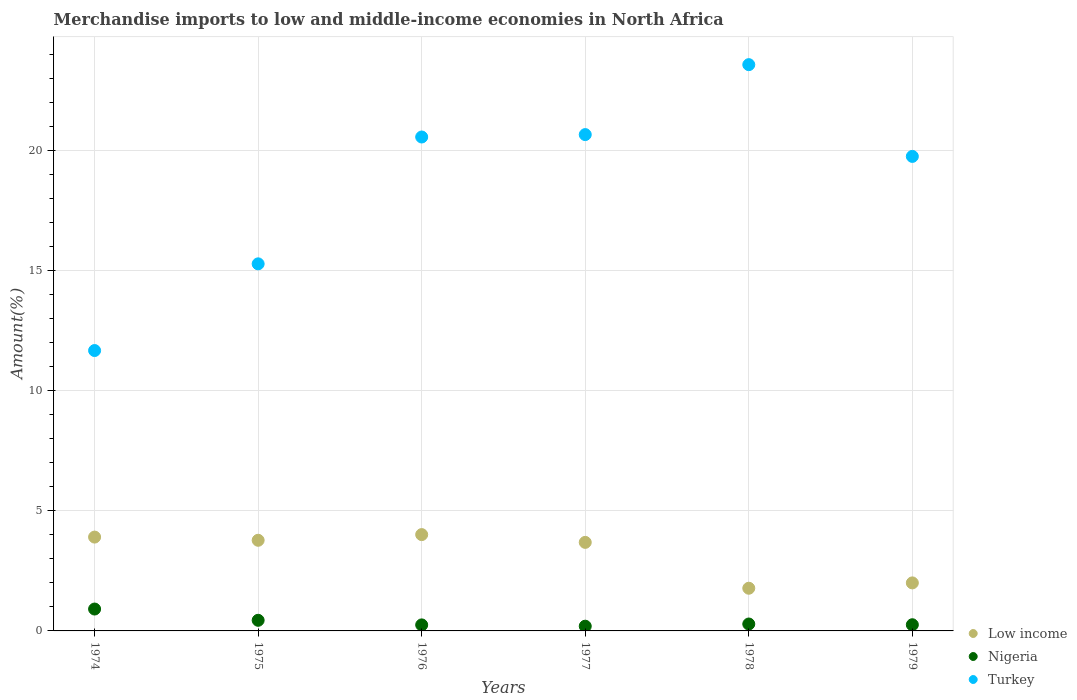How many different coloured dotlines are there?
Give a very brief answer. 3. Is the number of dotlines equal to the number of legend labels?
Make the answer very short. Yes. What is the percentage of amount earned from merchandise imports in Turkey in 1974?
Give a very brief answer. 11.68. Across all years, what is the maximum percentage of amount earned from merchandise imports in Turkey?
Keep it short and to the point. 23.6. Across all years, what is the minimum percentage of amount earned from merchandise imports in Turkey?
Offer a very short reply. 11.68. In which year was the percentage of amount earned from merchandise imports in Low income maximum?
Give a very brief answer. 1976. In which year was the percentage of amount earned from merchandise imports in Turkey minimum?
Provide a short and direct response. 1974. What is the total percentage of amount earned from merchandise imports in Low income in the graph?
Make the answer very short. 19.17. What is the difference between the percentage of amount earned from merchandise imports in Turkey in 1974 and that in 1976?
Keep it short and to the point. -8.9. What is the difference between the percentage of amount earned from merchandise imports in Low income in 1975 and the percentage of amount earned from merchandise imports in Turkey in 1978?
Offer a very short reply. -19.82. What is the average percentage of amount earned from merchandise imports in Turkey per year?
Offer a terse response. 18.6. In the year 1977, what is the difference between the percentage of amount earned from merchandise imports in Low income and percentage of amount earned from merchandise imports in Nigeria?
Your answer should be compact. 3.49. In how many years, is the percentage of amount earned from merchandise imports in Low income greater than 6 %?
Keep it short and to the point. 0. What is the ratio of the percentage of amount earned from merchandise imports in Low income in 1974 to that in 1978?
Ensure brevity in your answer.  2.2. Is the percentage of amount earned from merchandise imports in Nigeria in 1974 less than that in 1976?
Your response must be concise. No. What is the difference between the highest and the second highest percentage of amount earned from merchandise imports in Turkey?
Make the answer very short. 2.91. What is the difference between the highest and the lowest percentage of amount earned from merchandise imports in Low income?
Your answer should be very brief. 2.24. In how many years, is the percentage of amount earned from merchandise imports in Turkey greater than the average percentage of amount earned from merchandise imports in Turkey taken over all years?
Provide a short and direct response. 4. Is the percentage of amount earned from merchandise imports in Turkey strictly greater than the percentage of amount earned from merchandise imports in Low income over the years?
Provide a short and direct response. Yes. What is the difference between two consecutive major ticks on the Y-axis?
Your answer should be very brief. 5. Does the graph contain any zero values?
Provide a succinct answer. No. Does the graph contain grids?
Your answer should be compact. Yes. Where does the legend appear in the graph?
Your response must be concise. Bottom right. How are the legend labels stacked?
Your response must be concise. Vertical. What is the title of the graph?
Keep it short and to the point. Merchandise imports to low and middle-income economies in North Africa. What is the label or title of the Y-axis?
Your answer should be compact. Amount(%). What is the Amount(%) of Low income in 1974?
Your answer should be compact. 3.91. What is the Amount(%) of Nigeria in 1974?
Your response must be concise. 0.91. What is the Amount(%) of Turkey in 1974?
Your answer should be very brief. 11.68. What is the Amount(%) of Low income in 1975?
Your response must be concise. 3.78. What is the Amount(%) in Nigeria in 1975?
Your response must be concise. 0.44. What is the Amount(%) in Turkey in 1975?
Keep it short and to the point. 15.3. What is the Amount(%) of Low income in 1976?
Your response must be concise. 4.01. What is the Amount(%) of Nigeria in 1976?
Ensure brevity in your answer.  0.25. What is the Amount(%) in Turkey in 1976?
Provide a succinct answer. 20.58. What is the Amount(%) in Low income in 1977?
Provide a succinct answer. 3.69. What is the Amount(%) in Nigeria in 1977?
Your response must be concise. 0.2. What is the Amount(%) in Turkey in 1977?
Provide a short and direct response. 20.68. What is the Amount(%) in Low income in 1978?
Your response must be concise. 1.78. What is the Amount(%) of Nigeria in 1978?
Provide a short and direct response. 0.29. What is the Amount(%) of Turkey in 1978?
Give a very brief answer. 23.6. What is the Amount(%) of Low income in 1979?
Provide a succinct answer. 2. What is the Amount(%) of Nigeria in 1979?
Your answer should be compact. 0.26. What is the Amount(%) in Turkey in 1979?
Your answer should be compact. 19.77. Across all years, what is the maximum Amount(%) of Low income?
Give a very brief answer. 4.01. Across all years, what is the maximum Amount(%) in Nigeria?
Give a very brief answer. 0.91. Across all years, what is the maximum Amount(%) in Turkey?
Make the answer very short. 23.6. Across all years, what is the minimum Amount(%) in Low income?
Your answer should be very brief. 1.78. Across all years, what is the minimum Amount(%) in Nigeria?
Your answer should be very brief. 0.2. Across all years, what is the minimum Amount(%) of Turkey?
Make the answer very short. 11.68. What is the total Amount(%) in Low income in the graph?
Offer a very short reply. 19.17. What is the total Amount(%) in Nigeria in the graph?
Your response must be concise. 2.35. What is the total Amount(%) in Turkey in the graph?
Your answer should be compact. 111.62. What is the difference between the Amount(%) in Low income in 1974 and that in 1975?
Make the answer very short. 0.13. What is the difference between the Amount(%) of Nigeria in 1974 and that in 1975?
Your answer should be very brief. 0.47. What is the difference between the Amount(%) in Turkey in 1974 and that in 1975?
Your answer should be compact. -3.61. What is the difference between the Amount(%) of Low income in 1974 and that in 1976?
Keep it short and to the point. -0.1. What is the difference between the Amount(%) in Nigeria in 1974 and that in 1976?
Offer a very short reply. 0.66. What is the difference between the Amount(%) of Turkey in 1974 and that in 1976?
Offer a terse response. -8.9. What is the difference between the Amount(%) of Low income in 1974 and that in 1977?
Provide a short and direct response. 0.22. What is the difference between the Amount(%) of Nigeria in 1974 and that in 1977?
Provide a succinct answer. 0.72. What is the difference between the Amount(%) in Turkey in 1974 and that in 1977?
Provide a succinct answer. -9. What is the difference between the Amount(%) in Low income in 1974 and that in 1978?
Your response must be concise. 2.13. What is the difference between the Amount(%) in Nigeria in 1974 and that in 1978?
Provide a succinct answer. 0.62. What is the difference between the Amount(%) in Turkey in 1974 and that in 1978?
Offer a very short reply. -11.91. What is the difference between the Amount(%) of Low income in 1974 and that in 1979?
Keep it short and to the point. 1.91. What is the difference between the Amount(%) of Nigeria in 1974 and that in 1979?
Give a very brief answer. 0.65. What is the difference between the Amount(%) in Turkey in 1974 and that in 1979?
Your response must be concise. -8.09. What is the difference between the Amount(%) of Low income in 1975 and that in 1976?
Give a very brief answer. -0.24. What is the difference between the Amount(%) of Nigeria in 1975 and that in 1976?
Give a very brief answer. 0.19. What is the difference between the Amount(%) of Turkey in 1975 and that in 1976?
Ensure brevity in your answer.  -5.29. What is the difference between the Amount(%) of Low income in 1975 and that in 1977?
Give a very brief answer. 0.09. What is the difference between the Amount(%) in Nigeria in 1975 and that in 1977?
Keep it short and to the point. 0.25. What is the difference between the Amount(%) in Turkey in 1975 and that in 1977?
Make the answer very short. -5.39. What is the difference between the Amount(%) of Low income in 1975 and that in 1978?
Your response must be concise. 2. What is the difference between the Amount(%) in Nigeria in 1975 and that in 1978?
Your answer should be very brief. 0.15. What is the difference between the Amount(%) of Turkey in 1975 and that in 1978?
Your answer should be very brief. -8.3. What is the difference between the Amount(%) in Low income in 1975 and that in 1979?
Offer a terse response. 1.78. What is the difference between the Amount(%) of Nigeria in 1975 and that in 1979?
Provide a succinct answer. 0.19. What is the difference between the Amount(%) of Turkey in 1975 and that in 1979?
Your answer should be compact. -4.48. What is the difference between the Amount(%) of Low income in 1976 and that in 1977?
Your response must be concise. 0.32. What is the difference between the Amount(%) in Nigeria in 1976 and that in 1977?
Offer a very short reply. 0.05. What is the difference between the Amount(%) in Turkey in 1976 and that in 1977?
Give a very brief answer. -0.1. What is the difference between the Amount(%) of Low income in 1976 and that in 1978?
Provide a short and direct response. 2.24. What is the difference between the Amount(%) in Nigeria in 1976 and that in 1978?
Ensure brevity in your answer.  -0.04. What is the difference between the Amount(%) of Turkey in 1976 and that in 1978?
Your answer should be compact. -3.01. What is the difference between the Amount(%) in Low income in 1976 and that in 1979?
Your answer should be very brief. 2.01. What is the difference between the Amount(%) of Nigeria in 1976 and that in 1979?
Keep it short and to the point. -0.01. What is the difference between the Amount(%) of Turkey in 1976 and that in 1979?
Provide a succinct answer. 0.81. What is the difference between the Amount(%) of Low income in 1977 and that in 1978?
Keep it short and to the point. 1.91. What is the difference between the Amount(%) of Nigeria in 1977 and that in 1978?
Your response must be concise. -0.09. What is the difference between the Amount(%) of Turkey in 1977 and that in 1978?
Offer a terse response. -2.91. What is the difference between the Amount(%) of Low income in 1977 and that in 1979?
Give a very brief answer. 1.69. What is the difference between the Amount(%) of Nigeria in 1977 and that in 1979?
Offer a terse response. -0.06. What is the difference between the Amount(%) in Turkey in 1977 and that in 1979?
Provide a succinct answer. 0.91. What is the difference between the Amount(%) in Low income in 1978 and that in 1979?
Your answer should be compact. -0.22. What is the difference between the Amount(%) in Nigeria in 1978 and that in 1979?
Provide a succinct answer. 0.03. What is the difference between the Amount(%) of Turkey in 1978 and that in 1979?
Your answer should be compact. 3.82. What is the difference between the Amount(%) of Low income in 1974 and the Amount(%) of Nigeria in 1975?
Offer a very short reply. 3.47. What is the difference between the Amount(%) in Low income in 1974 and the Amount(%) in Turkey in 1975?
Ensure brevity in your answer.  -11.39. What is the difference between the Amount(%) in Nigeria in 1974 and the Amount(%) in Turkey in 1975?
Provide a succinct answer. -14.38. What is the difference between the Amount(%) of Low income in 1974 and the Amount(%) of Nigeria in 1976?
Make the answer very short. 3.66. What is the difference between the Amount(%) of Low income in 1974 and the Amount(%) of Turkey in 1976?
Your response must be concise. -16.67. What is the difference between the Amount(%) in Nigeria in 1974 and the Amount(%) in Turkey in 1976?
Offer a terse response. -19.67. What is the difference between the Amount(%) of Low income in 1974 and the Amount(%) of Nigeria in 1977?
Your response must be concise. 3.71. What is the difference between the Amount(%) in Low income in 1974 and the Amount(%) in Turkey in 1977?
Offer a terse response. -16.77. What is the difference between the Amount(%) in Nigeria in 1974 and the Amount(%) in Turkey in 1977?
Make the answer very short. -19.77. What is the difference between the Amount(%) of Low income in 1974 and the Amount(%) of Nigeria in 1978?
Give a very brief answer. 3.62. What is the difference between the Amount(%) in Low income in 1974 and the Amount(%) in Turkey in 1978?
Offer a terse response. -19.69. What is the difference between the Amount(%) of Nigeria in 1974 and the Amount(%) of Turkey in 1978?
Your answer should be very brief. -22.68. What is the difference between the Amount(%) in Low income in 1974 and the Amount(%) in Nigeria in 1979?
Keep it short and to the point. 3.65. What is the difference between the Amount(%) of Low income in 1974 and the Amount(%) of Turkey in 1979?
Provide a succinct answer. -15.86. What is the difference between the Amount(%) in Nigeria in 1974 and the Amount(%) in Turkey in 1979?
Keep it short and to the point. -18.86. What is the difference between the Amount(%) in Low income in 1975 and the Amount(%) in Nigeria in 1976?
Offer a terse response. 3.53. What is the difference between the Amount(%) in Low income in 1975 and the Amount(%) in Turkey in 1976?
Keep it short and to the point. -16.81. What is the difference between the Amount(%) in Nigeria in 1975 and the Amount(%) in Turkey in 1976?
Offer a very short reply. -20.14. What is the difference between the Amount(%) of Low income in 1975 and the Amount(%) of Nigeria in 1977?
Offer a terse response. 3.58. What is the difference between the Amount(%) of Low income in 1975 and the Amount(%) of Turkey in 1977?
Make the answer very short. -16.91. What is the difference between the Amount(%) in Nigeria in 1975 and the Amount(%) in Turkey in 1977?
Offer a very short reply. -20.24. What is the difference between the Amount(%) of Low income in 1975 and the Amount(%) of Nigeria in 1978?
Offer a terse response. 3.49. What is the difference between the Amount(%) in Low income in 1975 and the Amount(%) in Turkey in 1978?
Offer a very short reply. -19.82. What is the difference between the Amount(%) of Nigeria in 1975 and the Amount(%) of Turkey in 1978?
Your answer should be very brief. -23.15. What is the difference between the Amount(%) of Low income in 1975 and the Amount(%) of Nigeria in 1979?
Your response must be concise. 3.52. What is the difference between the Amount(%) of Low income in 1975 and the Amount(%) of Turkey in 1979?
Provide a succinct answer. -16. What is the difference between the Amount(%) of Nigeria in 1975 and the Amount(%) of Turkey in 1979?
Give a very brief answer. -19.33. What is the difference between the Amount(%) in Low income in 1976 and the Amount(%) in Nigeria in 1977?
Keep it short and to the point. 3.82. What is the difference between the Amount(%) of Low income in 1976 and the Amount(%) of Turkey in 1977?
Offer a very short reply. -16.67. What is the difference between the Amount(%) in Nigeria in 1976 and the Amount(%) in Turkey in 1977?
Keep it short and to the point. -20.43. What is the difference between the Amount(%) of Low income in 1976 and the Amount(%) of Nigeria in 1978?
Provide a short and direct response. 3.73. What is the difference between the Amount(%) in Low income in 1976 and the Amount(%) in Turkey in 1978?
Ensure brevity in your answer.  -19.58. What is the difference between the Amount(%) of Nigeria in 1976 and the Amount(%) of Turkey in 1978?
Ensure brevity in your answer.  -23.35. What is the difference between the Amount(%) of Low income in 1976 and the Amount(%) of Nigeria in 1979?
Ensure brevity in your answer.  3.76. What is the difference between the Amount(%) of Low income in 1976 and the Amount(%) of Turkey in 1979?
Your answer should be very brief. -15.76. What is the difference between the Amount(%) of Nigeria in 1976 and the Amount(%) of Turkey in 1979?
Provide a succinct answer. -19.52. What is the difference between the Amount(%) in Low income in 1977 and the Amount(%) in Nigeria in 1978?
Give a very brief answer. 3.4. What is the difference between the Amount(%) of Low income in 1977 and the Amount(%) of Turkey in 1978?
Make the answer very short. -19.91. What is the difference between the Amount(%) of Nigeria in 1977 and the Amount(%) of Turkey in 1978?
Your answer should be compact. -23.4. What is the difference between the Amount(%) in Low income in 1977 and the Amount(%) in Nigeria in 1979?
Ensure brevity in your answer.  3.43. What is the difference between the Amount(%) of Low income in 1977 and the Amount(%) of Turkey in 1979?
Provide a succinct answer. -16.08. What is the difference between the Amount(%) of Nigeria in 1977 and the Amount(%) of Turkey in 1979?
Provide a succinct answer. -19.58. What is the difference between the Amount(%) in Low income in 1978 and the Amount(%) in Nigeria in 1979?
Your answer should be very brief. 1.52. What is the difference between the Amount(%) in Low income in 1978 and the Amount(%) in Turkey in 1979?
Your response must be concise. -18. What is the difference between the Amount(%) of Nigeria in 1978 and the Amount(%) of Turkey in 1979?
Ensure brevity in your answer.  -19.49. What is the average Amount(%) of Low income per year?
Provide a succinct answer. 3.2. What is the average Amount(%) in Nigeria per year?
Your answer should be compact. 0.39. What is the average Amount(%) in Turkey per year?
Keep it short and to the point. 18.6. In the year 1974, what is the difference between the Amount(%) in Low income and Amount(%) in Nigeria?
Ensure brevity in your answer.  3. In the year 1974, what is the difference between the Amount(%) of Low income and Amount(%) of Turkey?
Provide a succinct answer. -7.77. In the year 1974, what is the difference between the Amount(%) in Nigeria and Amount(%) in Turkey?
Offer a terse response. -10.77. In the year 1975, what is the difference between the Amount(%) of Low income and Amount(%) of Nigeria?
Ensure brevity in your answer.  3.33. In the year 1975, what is the difference between the Amount(%) in Low income and Amount(%) in Turkey?
Ensure brevity in your answer.  -11.52. In the year 1975, what is the difference between the Amount(%) of Nigeria and Amount(%) of Turkey?
Your response must be concise. -14.85. In the year 1976, what is the difference between the Amount(%) in Low income and Amount(%) in Nigeria?
Ensure brevity in your answer.  3.76. In the year 1976, what is the difference between the Amount(%) of Low income and Amount(%) of Turkey?
Your response must be concise. -16.57. In the year 1976, what is the difference between the Amount(%) of Nigeria and Amount(%) of Turkey?
Offer a very short reply. -20.33. In the year 1977, what is the difference between the Amount(%) in Low income and Amount(%) in Nigeria?
Offer a very short reply. 3.49. In the year 1977, what is the difference between the Amount(%) in Low income and Amount(%) in Turkey?
Your answer should be compact. -16.99. In the year 1977, what is the difference between the Amount(%) in Nigeria and Amount(%) in Turkey?
Offer a terse response. -20.49. In the year 1978, what is the difference between the Amount(%) of Low income and Amount(%) of Nigeria?
Your answer should be very brief. 1.49. In the year 1978, what is the difference between the Amount(%) of Low income and Amount(%) of Turkey?
Offer a very short reply. -21.82. In the year 1978, what is the difference between the Amount(%) of Nigeria and Amount(%) of Turkey?
Provide a succinct answer. -23.31. In the year 1979, what is the difference between the Amount(%) of Low income and Amount(%) of Nigeria?
Provide a short and direct response. 1.74. In the year 1979, what is the difference between the Amount(%) of Low income and Amount(%) of Turkey?
Your answer should be compact. -17.77. In the year 1979, what is the difference between the Amount(%) of Nigeria and Amount(%) of Turkey?
Offer a terse response. -19.52. What is the ratio of the Amount(%) in Low income in 1974 to that in 1975?
Provide a succinct answer. 1.04. What is the ratio of the Amount(%) of Nigeria in 1974 to that in 1975?
Your response must be concise. 2.06. What is the ratio of the Amount(%) of Turkey in 1974 to that in 1975?
Give a very brief answer. 0.76. What is the ratio of the Amount(%) of Low income in 1974 to that in 1976?
Your answer should be compact. 0.97. What is the ratio of the Amount(%) in Nigeria in 1974 to that in 1976?
Provide a short and direct response. 3.64. What is the ratio of the Amount(%) of Turkey in 1974 to that in 1976?
Your response must be concise. 0.57. What is the ratio of the Amount(%) in Low income in 1974 to that in 1977?
Offer a very short reply. 1.06. What is the ratio of the Amount(%) of Nigeria in 1974 to that in 1977?
Offer a terse response. 4.63. What is the ratio of the Amount(%) of Turkey in 1974 to that in 1977?
Your answer should be very brief. 0.56. What is the ratio of the Amount(%) in Low income in 1974 to that in 1978?
Offer a very short reply. 2.2. What is the ratio of the Amount(%) in Nigeria in 1974 to that in 1978?
Your response must be concise. 3.17. What is the ratio of the Amount(%) of Turkey in 1974 to that in 1978?
Your answer should be compact. 0.5. What is the ratio of the Amount(%) of Low income in 1974 to that in 1979?
Provide a succinct answer. 1.95. What is the ratio of the Amount(%) in Nigeria in 1974 to that in 1979?
Ensure brevity in your answer.  3.54. What is the ratio of the Amount(%) in Turkey in 1974 to that in 1979?
Offer a very short reply. 0.59. What is the ratio of the Amount(%) in Low income in 1975 to that in 1976?
Your response must be concise. 0.94. What is the ratio of the Amount(%) in Nigeria in 1975 to that in 1976?
Give a very brief answer. 1.76. What is the ratio of the Amount(%) in Turkey in 1975 to that in 1976?
Your response must be concise. 0.74. What is the ratio of the Amount(%) in Low income in 1975 to that in 1977?
Your answer should be compact. 1.02. What is the ratio of the Amount(%) in Nigeria in 1975 to that in 1977?
Your answer should be compact. 2.25. What is the ratio of the Amount(%) in Turkey in 1975 to that in 1977?
Keep it short and to the point. 0.74. What is the ratio of the Amount(%) in Low income in 1975 to that in 1978?
Your answer should be compact. 2.12. What is the ratio of the Amount(%) of Nigeria in 1975 to that in 1978?
Make the answer very short. 1.54. What is the ratio of the Amount(%) of Turkey in 1975 to that in 1978?
Offer a terse response. 0.65. What is the ratio of the Amount(%) in Low income in 1975 to that in 1979?
Provide a succinct answer. 1.89. What is the ratio of the Amount(%) of Nigeria in 1975 to that in 1979?
Make the answer very short. 1.72. What is the ratio of the Amount(%) of Turkey in 1975 to that in 1979?
Offer a terse response. 0.77. What is the ratio of the Amount(%) of Low income in 1976 to that in 1977?
Provide a short and direct response. 1.09. What is the ratio of the Amount(%) in Nigeria in 1976 to that in 1977?
Offer a very short reply. 1.27. What is the ratio of the Amount(%) in Low income in 1976 to that in 1978?
Make the answer very short. 2.26. What is the ratio of the Amount(%) of Nigeria in 1976 to that in 1978?
Offer a terse response. 0.87. What is the ratio of the Amount(%) of Turkey in 1976 to that in 1978?
Ensure brevity in your answer.  0.87. What is the ratio of the Amount(%) of Low income in 1976 to that in 1979?
Offer a very short reply. 2.01. What is the ratio of the Amount(%) of Nigeria in 1976 to that in 1979?
Provide a succinct answer. 0.97. What is the ratio of the Amount(%) of Turkey in 1976 to that in 1979?
Offer a terse response. 1.04. What is the ratio of the Amount(%) of Low income in 1977 to that in 1978?
Your answer should be compact. 2.07. What is the ratio of the Amount(%) in Nigeria in 1977 to that in 1978?
Give a very brief answer. 0.68. What is the ratio of the Amount(%) of Turkey in 1977 to that in 1978?
Provide a short and direct response. 0.88. What is the ratio of the Amount(%) in Low income in 1977 to that in 1979?
Your answer should be very brief. 1.84. What is the ratio of the Amount(%) of Nigeria in 1977 to that in 1979?
Keep it short and to the point. 0.76. What is the ratio of the Amount(%) in Turkey in 1977 to that in 1979?
Provide a succinct answer. 1.05. What is the ratio of the Amount(%) of Low income in 1978 to that in 1979?
Your answer should be very brief. 0.89. What is the ratio of the Amount(%) of Nigeria in 1978 to that in 1979?
Ensure brevity in your answer.  1.12. What is the ratio of the Amount(%) of Turkey in 1978 to that in 1979?
Provide a succinct answer. 1.19. What is the difference between the highest and the second highest Amount(%) of Low income?
Your response must be concise. 0.1. What is the difference between the highest and the second highest Amount(%) of Nigeria?
Provide a short and direct response. 0.47. What is the difference between the highest and the second highest Amount(%) in Turkey?
Make the answer very short. 2.91. What is the difference between the highest and the lowest Amount(%) in Low income?
Offer a terse response. 2.24. What is the difference between the highest and the lowest Amount(%) in Nigeria?
Offer a terse response. 0.72. What is the difference between the highest and the lowest Amount(%) in Turkey?
Make the answer very short. 11.91. 